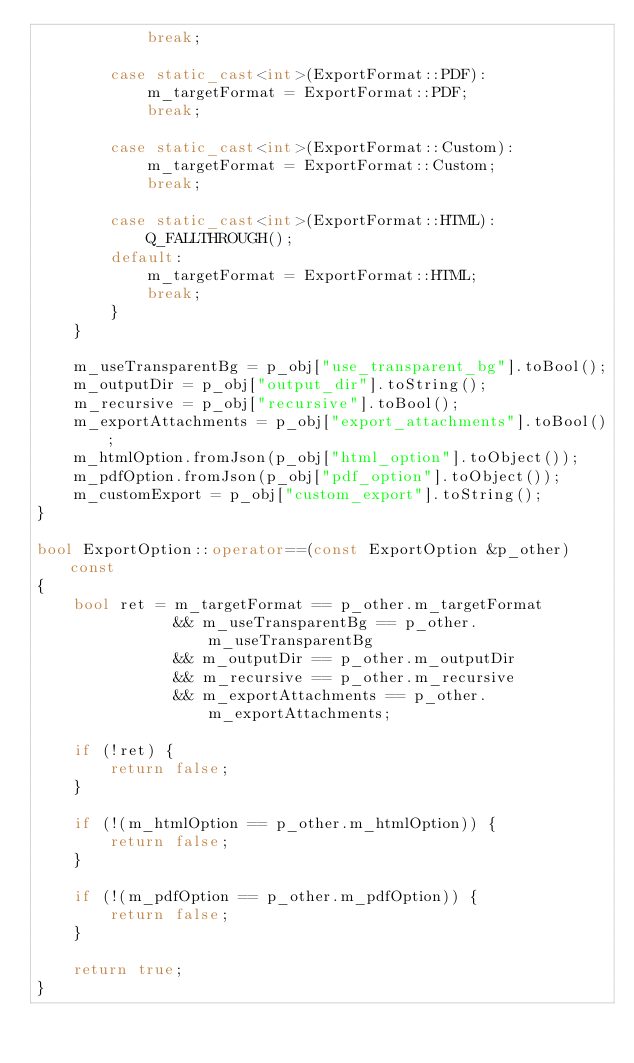<code> <loc_0><loc_0><loc_500><loc_500><_C++_>            break;

        case static_cast<int>(ExportFormat::PDF):
            m_targetFormat = ExportFormat::PDF;
            break;

        case static_cast<int>(ExportFormat::Custom):
            m_targetFormat = ExportFormat::Custom;
            break;

        case static_cast<int>(ExportFormat::HTML):
            Q_FALLTHROUGH();
        default:
            m_targetFormat = ExportFormat::HTML;
            break;
        }
    }

    m_useTransparentBg = p_obj["use_transparent_bg"].toBool();
    m_outputDir = p_obj["output_dir"].toString();
    m_recursive = p_obj["recursive"].toBool();
    m_exportAttachments = p_obj["export_attachments"].toBool();
    m_htmlOption.fromJson(p_obj["html_option"].toObject());
    m_pdfOption.fromJson(p_obj["pdf_option"].toObject());
    m_customExport = p_obj["custom_export"].toString();
}

bool ExportOption::operator==(const ExportOption &p_other) const
{
    bool ret = m_targetFormat == p_other.m_targetFormat
               && m_useTransparentBg == p_other.m_useTransparentBg
               && m_outputDir == p_other.m_outputDir
               && m_recursive == p_other.m_recursive
               && m_exportAttachments == p_other.m_exportAttachments;

    if (!ret) {
        return false;
    }

    if (!(m_htmlOption == p_other.m_htmlOption)) {
        return false;
    }

    if (!(m_pdfOption == p_other.m_pdfOption)) {
        return false;
    }

    return true;
}
</code> 